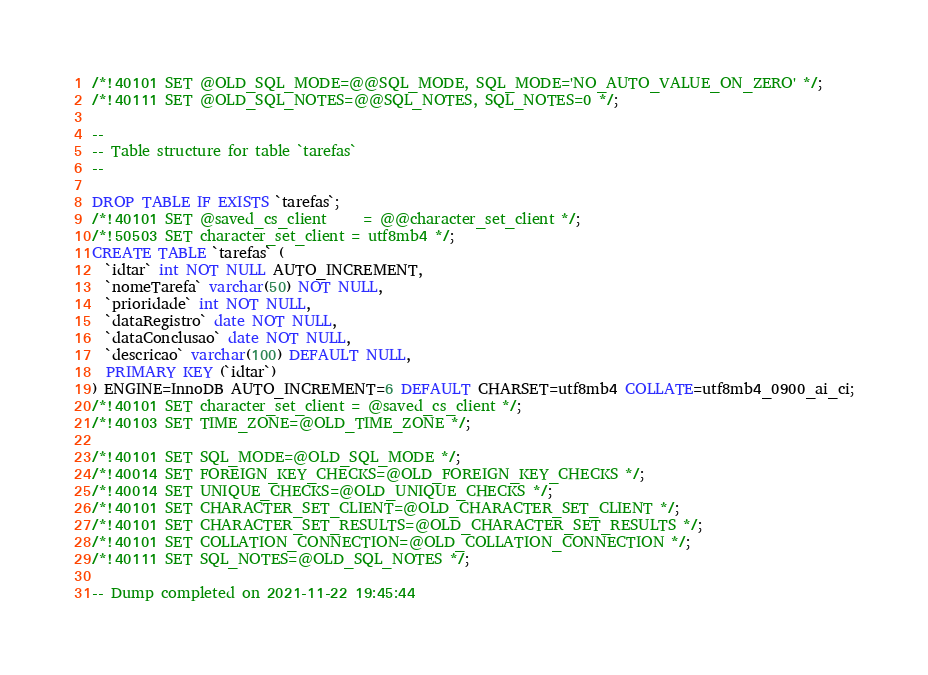<code> <loc_0><loc_0><loc_500><loc_500><_SQL_>/*!40101 SET @OLD_SQL_MODE=@@SQL_MODE, SQL_MODE='NO_AUTO_VALUE_ON_ZERO' */;
/*!40111 SET @OLD_SQL_NOTES=@@SQL_NOTES, SQL_NOTES=0 */;

--
-- Table structure for table `tarefas`
--

DROP TABLE IF EXISTS `tarefas`;
/*!40101 SET @saved_cs_client     = @@character_set_client */;
/*!50503 SET character_set_client = utf8mb4 */;
CREATE TABLE `tarefas` (
  `idtar` int NOT NULL AUTO_INCREMENT,
  `nomeTarefa` varchar(50) NOT NULL,
  `prioridade` int NOT NULL,
  `dataRegistro` date NOT NULL,
  `dataConclusao` date NOT NULL,
  `descricao` varchar(100) DEFAULT NULL,
  PRIMARY KEY (`idtar`)
) ENGINE=InnoDB AUTO_INCREMENT=6 DEFAULT CHARSET=utf8mb4 COLLATE=utf8mb4_0900_ai_ci;
/*!40101 SET character_set_client = @saved_cs_client */;
/*!40103 SET TIME_ZONE=@OLD_TIME_ZONE */;

/*!40101 SET SQL_MODE=@OLD_SQL_MODE */;
/*!40014 SET FOREIGN_KEY_CHECKS=@OLD_FOREIGN_KEY_CHECKS */;
/*!40014 SET UNIQUE_CHECKS=@OLD_UNIQUE_CHECKS */;
/*!40101 SET CHARACTER_SET_CLIENT=@OLD_CHARACTER_SET_CLIENT */;
/*!40101 SET CHARACTER_SET_RESULTS=@OLD_CHARACTER_SET_RESULTS */;
/*!40101 SET COLLATION_CONNECTION=@OLD_COLLATION_CONNECTION */;
/*!40111 SET SQL_NOTES=@OLD_SQL_NOTES */;

-- Dump completed on 2021-11-22 19:45:44
</code> 